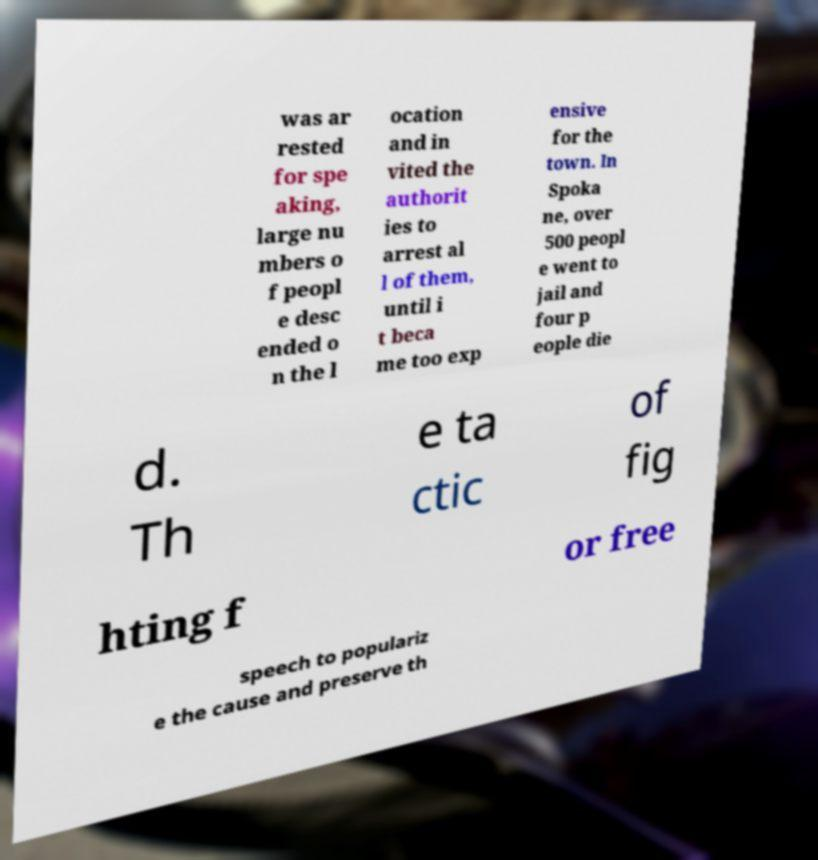Could you extract and type out the text from this image? was ar rested for spe aking, large nu mbers o f peopl e desc ended o n the l ocation and in vited the authorit ies to arrest al l of them, until i t beca me too exp ensive for the town. In Spoka ne, over 500 peopl e went to jail and four p eople die d. Th e ta ctic of fig hting f or free speech to populariz e the cause and preserve th 